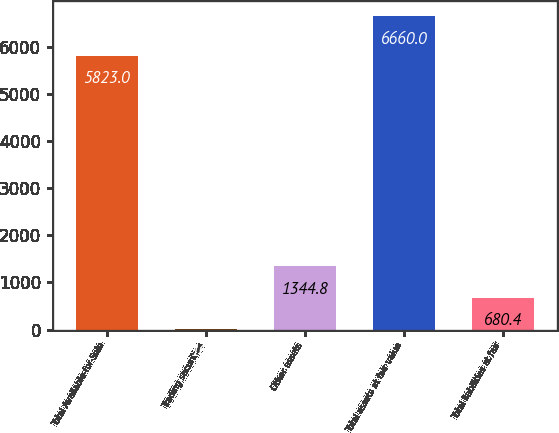Convert chart to OTSL. <chart><loc_0><loc_0><loc_500><loc_500><bar_chart><fcel>Total Available-for-Sale<fcel>Trading securities<fcel>Other assets<fcel>Total assets at fair value<fcel>Total liabilities at fair<nl><fcel>5823<fcel>16<fcel>1344.8<fcel>6660<fcel>680.4<nl></chart> 